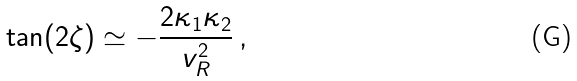<formula> <loc_0><loc_0><loc_500><loc_500>\tan ( 2 \zeta ) \simeq - \frac { 2 \kappa _ { 1 } \kappa _ { 2 } } { v _ { R } ^ { 2 } } \, ,</formula> 